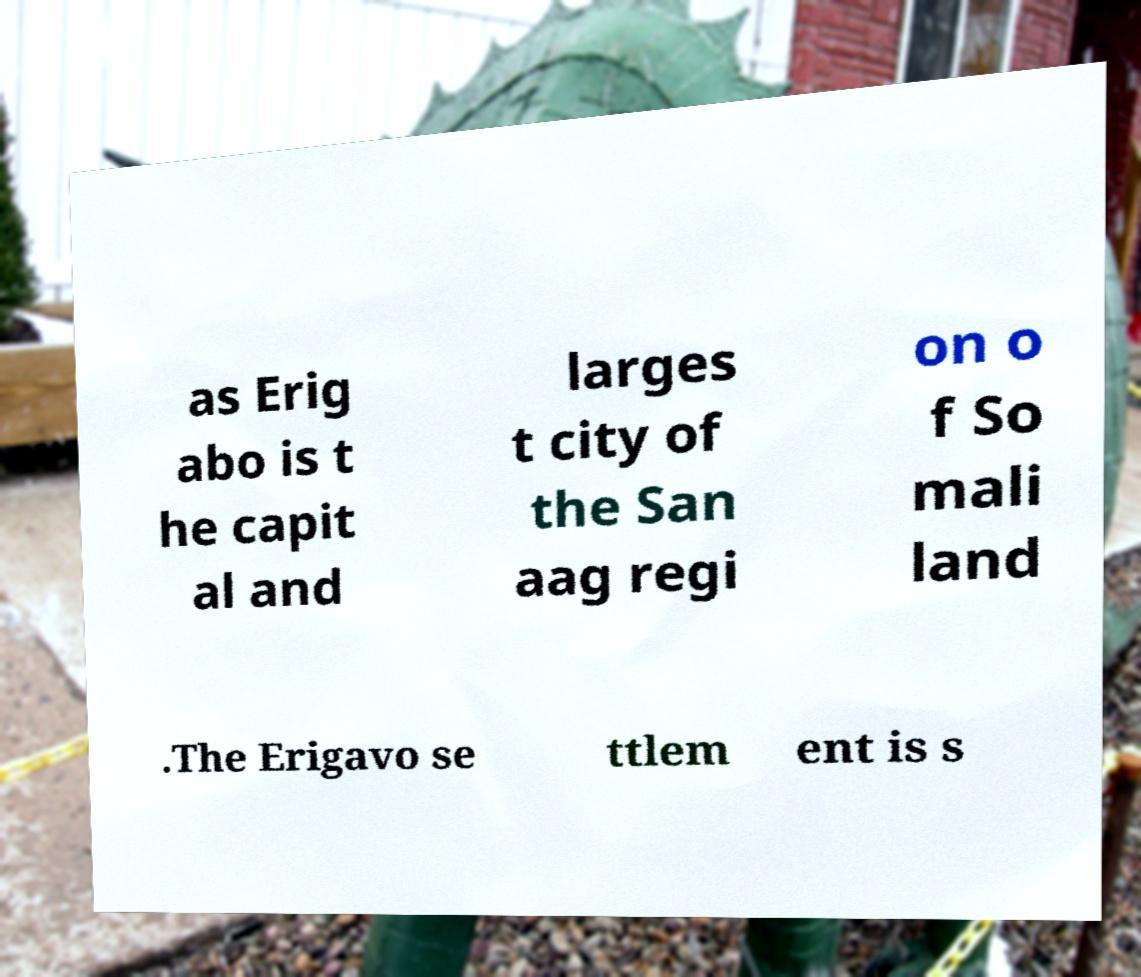Please identify and transcribe the text found in this image. as Erig abo is t he capit al and larges t city of the San aag regi on o f So mali land .The Erigavo se ttlem ent is s 